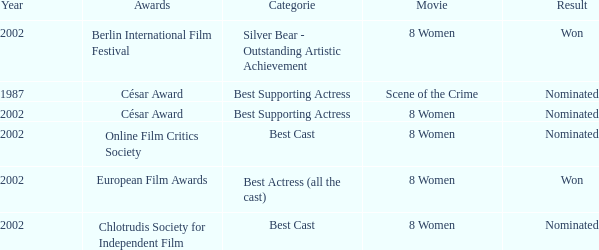In what year was the movie 8 women up for a César Award? 2002.0. 